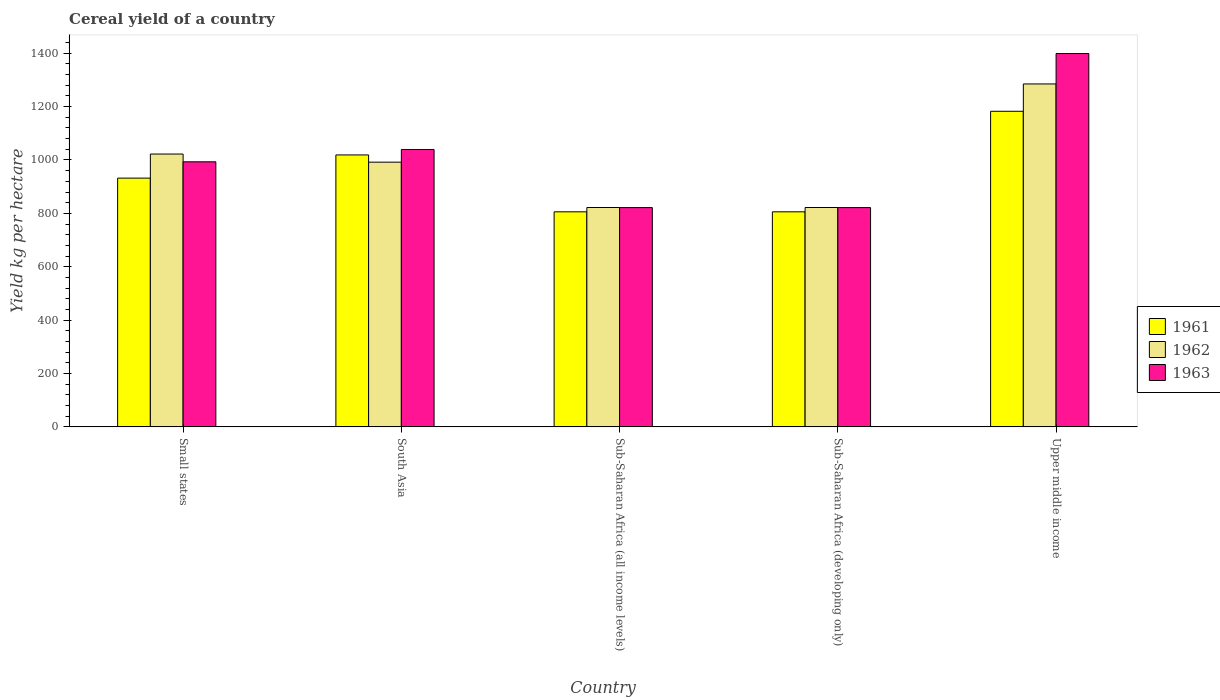Are the number of bars per tick equal to the number of legend labels?
Offer a very short reply. Yes. Are the number of bars on each tick of the X-axis equal?
Your answer should be very brief. Yes. How many bars are there on the 2nd tick from the left?
Keep it short and to the point. 3. What is the label of the 4th group of bars from the left?
Offer a terse response. Sub-Saharan Africa (developing only). What is the total cereal yield in 1963 in Sub-Saharan Africa (all income levels)?
Give a very brief answer. 821.71. Across all countries, what is the maximum total cereal yield in 1963?
Your answer should be very brief. 1398.9. Across all countries, what is the minimum total cereal yield in 1963?
Your response must be concise. 821.71. In which country was the total cereal yield in 1963 maximum?
Make the answer very short. Upper middle income. In which country was the total cereal yield in 1963 minimum?
Keep it short and to the point. Sub-Saharan Africa (all income levels). What is the total total cereal yield in 1961 in the graph?
Ensure brevity in your answer.  4745.3. What is the difference between the total cereal yield in 1962 in Sub-Saharan Africa (all income levels) and that in Sub-Saharan Africa (developing only)?
Keep it short and to the point. 0. What is the difference between the total cereal yield in 1963 in Small states and the total cereal yield in 1962 in South Asia?
Your answer should be very brief. 1.35. What is the average total cereal yield in 1963 per country?
Offer a terse response. 1015. What is the difference between the total cereal yield of/in 1961 and total cereal yield of/in 1962 in South Asia?
Offer a very short reply. 27.06. What is the ratio of the total cereal yield in 1962 in South Asia to that in Upper middle income?
Offer a terse response. 0.77. Is the total cereal yield in 1961 in Small states less than that in Upper middle income?
Make the answer very short. Yes. Is the difference between the total cereal yield in 1961 in Small states and South Asia greater than the difference between the total cereal yield in 1962 in Small states and South Asia?
Offer a very short reply. No. What is the difference between the highest and the second highest total cereal yield in 1962?
Your response must be concise. 262.66. What is the difference between the highest and the lowest total cereal yield in 1962?
Offer a terse response. 463. In how many countries, is the total cereal yield in 1962 greater than the average total cereal yield in 1962 taken over all countries?
Your response must be concise. 3. Is the sum of the total cereal yield in 1963 in Sub-Saharan Africa (all income levels) and Sub-Saharan Africa (developing only) greater than the maximum total cereal yield in 1961 across all countries?
Provide a short and direct response. Yes. What does the 1st bar from the left in Sub-Saharan Africa (developing only) represents?
Make the answer very short. 1961. How many bars are there?
Offer a very short reply. 15. Are all the bars in the graph horizontal?
Give a very brief answer. No. Are the values on the major ticks of Y-axis written in scientific E-notation?
Keep it short and to the point. No. Does the graph contain grids?
Give a very brief answer. No. What is the title of the graph?
Provide a succinct answer. Cereal yield of a country. What is the label or title of the X-axis?
Keep it short and to the point. Country. What is the label or title of the Y-axis?
Your answer should be compact. Yield kg per hectare. What is the Yield kg per hectare in 1961 in Small states?
Offer a very short reply. 932.09. What is the Yield kg per hectare of 1962 in Small states?
Your answer should be very brief. 1022.32. What is the Yield kg per hectare of 1963 in Small states?
Offer a terse response. 993.25. What is the Yield kg per hectare of 1961 in South Asia?
Offer a terse response. 1018.97. What is the Yield kg per hectare in 1962 in South Asia?
Provide a succinct answer. 991.91. What is the Yield kg per hectare of 1963 in South Asia?
Your answer should be compact. 1039.43. What is the Yield kg per hectare of 1961 in Sub-Saharan Africa (all income levels)?
Offer a very short reply. 805.83. What is the Yield kg per hectare of 1962 in Sub-Saharan Africa (all income levels)?
Provide a succinct answer. 821.98. What is the Yield kg per hectare of 1963 in Sub-Saharan Africa (all income levels)?
Offer a very short reply. 821.71. What is the Yield kg per hectare in 1961 in Sub-Saharan Africa (developing only)?
Keep it short and to the point. 805.83. What is the Yield kg per hectare of 1962 in Sub-Saharan Africa (developing only)?
Offer a very short reply. 821.98. What is the Yield kg per hectare of 1963 in Sub-Saharan Africa (developing only)?
Your response must be concise. 821.71. What is the Yield kg per hectare of 1961 in Upper middle income?
Provide a succinct answer. 1182.58. What is the Yield kg per hectare in 1962 in Upper middle income?
Ensure brevity in your answer.  1284.98. What is the Yield kg per hectare of 1963 in Upper middle income?
Provide a succinct answer. 1398.9. Across all countries, what is the maximum Yield kg per hectare in 1961?
Your answer should be compact. 1182.58. Across all countries, what is the maximum Yield kg per hectare of 1962?
Offer a very short reply. 1284.98. Across all countries, what is the maximum Yield kg per hectare of 1963?
Ensure brevity in your answer.  1398.9. Across all countries, what is the minimum Yield kg per hectare in 1961?
Give a very brief answer. 805.83. Across all countries, what is the minimum Yield kg per hectare in 1962?
Your answer should be very brief. 821.98. Across all countries, what is the minimum Yield kg per hectare in 1963?
Provide a succinct answer. 821.71. What is the total Yield kg per hectare of 1961 in the graph?
Provide a succinct answer. 4745.3. What is the total Yield kg per hectare in 1962 in the graph?
Provide a short and direct response. 4943.16. What is the total Yield kg per hectare in 1963 in the graph?
Keep it short and to the point. 5075. What is the difference between the Yield kg per hectare of 1961 in Small states and that in South Asia?
Make the answer very short. -86.87. What is the difference between the Yield kg per hectare of 1962 in Small states and that in South Asia?
Your answer should be compact. 30.41. What is the difference between the Yield kg per hectare of 1963 in Small states and that in South Asia?
Provide a short and direct response. -46.18. What is the difference between the Yield kg per hectare of 1961 in Small states and that in Sub-Saharan Africa (all income levels)?
Your answer should be very brief. 126.26. What is the difference between the Yield kg per hectare in 1962 in Small states and that in Sub-Saharan Africa (all income levels)?
Offer a terse response. 200.34. What is the difference between the Yield kg per hectare in 1963 in Small states and that in Sub-Saharan Africa (all income levels)?
Offer a very short reply. 171.55. What is the difference between the Yield kg per hectare of 1961 in Small states and that in Sub-Saharan Africa (developing only)?
Your response must be concise. 126.26. What is the difference between the Yield kg per hectare in 1962 in Small states and that in Sub-Saharan Africa (developing only)?
Provide a succinct answer. 200.34. What is the difference between the Yield kg per hectare in 1963 in Small states and that in Sub-Saharan Africa (developing only)?
Your response must be concise. 171.55. What is the difference between the Yield kg per hectare of 1961 in Small states and that in Upper middle income?
Offer a very short reply. -250.48. What is the difference between the Yield kg per hectare of 1962 in Small states and that in Upper middle income?
Your answer should be very brief. -262.66. What is the difference between the Yield kg per hectare in 1963 in Small states and that in Upper middle income?
Your response must be concise. -405.65. What is the difference between the Yield kg per hectare in 1961 in South Asia and that in Sub-Saharan Africa (all income levels)?
Ensure brevity in your answer.  213.14. What is the difference between the Yield kg per hectare of 1962 in South Asia and that in Sub-Saharan Africa (all income levels)?
Your response must be concise. 169.93. What is the difference between the Yield kg per hectare in 1963 in South Asia and that in Sub-Saharan Africa (all income levels)?
Keep it short and to the point. 217.72. What is the difference between the Yield kg per hectare of 1961 in South Asia and that in Sub-Saharan Africa (developing only)?
Your answer should be very brief. 213.14. What is the difference between the Yield kg per hectare of 1962 in South Asia and that in Sub-Saharan Africa (developing only)?
Offer a very short reply. 169.93. What is the difference between the Yield kg per hectare in 1963 in South Asia and that in Sub-Saharan Africa (developing only)?
Give a very brief answer. 217.72. What is the difference between the Yield kg per hectare in 1961 in South Asia and that in Upper middle income?
Your response must be concise. -163.61. What is the difference between the Yield kg per hectare in 1962 in South Asia and that in Upper middle income?
Offer a very short reply. -293.07. What is the difference between the Yield kg per hectare of 1963 in South Asia and that in Upper middle income?
Make the answer very short. -359.47. What is the difference between the Yield kg per hectare of 1961 in Sub-Saharan Africa (all income levels) and that in Sub-Saharan Africa (developing only)?
Make the answer very short. 0. What is the difference between the Yield kg per hectare of 1962 in Sub-Saharan Africa (all income levels) and that in Sub-Saharan Africa (developing only)?
Your answer should be very brief. 0. What is the difference between the Yield kg per hectare in 1963 in Sub-Saharan Africa (all income levels) and that in Sub-Saharan Africa (developing only)?
Offer a very short reply. 0. What is the difference between the Yield kg per hectare of 1961 in Sub-Saharan Africa (all income levels) and that in Upper middle income?
Give a very brief answer. -376.75. What is the difference between the Yield kg per hectare of 1962 in Sub-Saharan Africa (all income levels) and that in Upper middle income?
Your answer should be compact. -463. What is the difference between the Yield kg per hectare in 1963 in Sub-Saharan Africa (all income levels) and that in Upper middle income?
Offer a terse response. -577.19. What is the difference between the Yield kg per hectare in 1961 in Sub-Saharan Africa (developing only) and that in Upper middle income?
Your answer should be compact. -376.75. What is the difference between the Yield kg per hectare of 1962 in Sub-Saharan Africa (developing only) and that in Upper middle income?
Offer a very short reply. -463. What is the difference between the Yield kg per hectare in 1963 in Sub-Saharan Africa (developing only) and that in Upper middle income?
Your answer should be compact. -577.19. What is the difference between the Yield kg per hectare of 1961 in Small states and the Yield kg per hectare of 1962 in South Asia?
Offer a terse response. -59.81. What is the difference between the Yield kg per hectare in 1961 in Small states and the Yield kg per hectare in 1963 in South Asia?
Your answer should be compact. -107.33. What is the difference between the Yield kg per hectare in 1962 in Small states and the Yield kg per hectare in 1963 in South Asia?
Your answer should be compact. -17.11. What is the difference between the Yield kg per hectare of 1961 in Small states and the Yield kg per hectare of 1962 in Sub-Saharan Africa (all income levels)?
Your answer should be compact. 110.12. What is the difference between the Yield kg per hectare of 1961 in Small states and the Yield kg per hectare of 1963 in Sub-Saharan Africa (all income levels)?
Your response must be concise. 110.39. What is the difference between the Yield kg per hectare of 1962 in Small states and the Yield kg per hectare of 1963 in Sub-Saharan Africa (all income levels)?
Give a very brief answer. 200.61. What is the difference between the Yield kg per hectare of 1961 in Small states and the Yield kg per hectare of 1962 in Sub-Saharan Africa (developing only)?
Provide a short and direct response. 110.12. What is the difference between the Yield kg per hectare of 1961 in Small states and the Yield kg per hectare of 1963 in Sub-Saharan Africa (developing only)?
Your answer should be compact. 110.39. What is the difference between the Yield kg per hectare of 1962 in Small states and the Yield kg per hectare of 1963 in Sub-Saharan Africa (developing only)?
Make the answer very short. 200.61. What is the difference between the Yield kg per hectare of 1961 in Small states and the Yield kg per hectare of 1962 in Upper middle income?
Provide a short and direct response. -352.88. What is the difference between the Yield kg per hectare in 1961 in Small states and the Yield kg per hectare in 1963 in Upper middle income?
Your answer should be compact. -466.81. What is the difference between the Yield kg per hectare of 1962 in Small states and the Yield kg per hectare of 1963 in Upper middle income?
Your answer should be compact. -376.58. What is the difference between the Yield kg per hectare in 1961 in South Asia and the Yield kg per hectare in 1962 in Sub-Saharan Africa (all income levels)?
Provide a succinct answer. 196.99. What is the difference between the Yield kg per hectare in 1961 in South Asia and the Yield kg per hectare in 1963 in Sub-Saharan Africa (all income levels)?
Provide a succinct answer. 197.26. What is the difference between the Yield kg per hectare in 1962 in South Asia and the Yield kg per hectare in 1963 in Sub-Saharan Africa (all income levels)?
Keep it short and to the point. 170.2. What is the difference between the Yield kg per hectare in 1961 in South Asia and the Yield kg per hectare in 1962 in Sub-Saharan Africa (developing only)?
Your response must be concise. 196.99. What is the difference between the Yield kg per hectare in 1961 in South Asia and the Yield kg per hectare in 1963 in Sub-Saharan Africa (developing only)?
Provide a short and direct response. 197.26. What is the difference between the Yield kg per hectare of 1962 in South Asia and the Yield kg per hectare of 1963 in Sub-Saharan Africa (developing only)?
Offer a terse response. 170.2. What is the difference between the Yield kg per hectare of 1961 in South Asia and the Yield kg per hectare of 1962 in Upper middle income?
Ensure brevity in your answer.  -266.01. What is the difference between the Yield kg per hectare in 1961 in South Asia and the Yield kg per hectare in 1963 in Upper middle income?
Your response must be concise. -379.94. What is the difference between the Yield kg per hectare of 1962 in South Asia and the Yield kg per hectare of 1963 in Upper middle income?
Your response must be concise. -407. What is the difference between the Yield kg per hectare of 1961 in Sub-Saharan Africa (all income levels) and the Yield kg per hectare of 1962 in Sub-Saharan Africa (developing only)?
Your response must be concise. -16.15. What is the difference between the Yield kg per hectare of 1961 in Sub-Saharan Africa (all income levels) and the Yield kg per hectare of 1963 in Sub-Saharan Africa (developing only)?
Offer a very short reply. -15.88. What is the difference between the Yield kg per hectare in 1962 in Sub-Saharan Africa (all income levels) and the Yield kg per hectare in 1963 in Sub-Saharan Africa (developing only)?
Your answer should be very brief. 0.27. What is the difference between the Yield kg per hectare in 1961 in Sub-Saharan Africa (all income levels) and the Yield kg per hectare in 1962 in Upper middle income?
Offer a very short reply. -479.15. What is the difference between the Yield kg per hectare of 1961 in Sub-Saharan Africa (all income levels) and the Yield kg per hectare of 1963 in Upper middle income?
Your response must be concise. -593.07. What is the difference between the Yield kg per hectare in 1962 in Sub-Saharan Africa (all income levels) and the Yield kg per hectare in 1963 in Upper middle income?
Your response must be concise. -576.92. What is the difference between the Yield kg per hectare of 1961 in Sub-Saharan Africa (developing only) and the Yield kg per hectare of 1962 in Upper middle income?
Provide a succinct answer. -479.15. What is the difference between the Yield kg per hectare of 1961 in Sub-Saharan Africa (developing only) and the Yield kg per hectare of 1963 in Upper middle income?
Your answer should be compact. -593.07. What is the difference between the Yield kg per hectare in 1962 in Sub-Saharan Africa (developing only) and the Yield kg per hectare in 1963 in Upper middle income?
Your answer should be compact. -576.92. What is the average Yield kg per hectare in 1961 per country?
Keep it short and to the point. 949.06. What is the average Yield kg per hectare in 1962 per country?
Your response must be concise. 988.63. What is the average Yield kg per hectare in 1963 per country?
Provide a short and direct response. 1015. What is the difference between the Yield kg per hectare in 1961 and Yield kg per hectare in 1962 in Small states?
Provide a succinct answer. -90.22. What is the difference between the Yield kg per hectare of 1961 and Yield kg per hectare of 1963 in Small states?
Provide a short and direct response. -61.16. What is the difference between the Yield kg per hectare of 1962 and Yield kg per hectare of 1963 in Small states?
Your response must be concise. 29.06. What is the difference between the Yield kg per hectare of 1961 and Yield kg per hectare of 1962 in South Asia?
Your answer should be compact. 27.06. What is the difference between the Yield kg per hectare in 1961 and Yield kg per hectare in 1963 in South Asia?
Make the answer very short. -20.46. What is the difference between the Yield kg per hectare in 1962 and Yield kg per hectare in 1963 in South Asia?
Give a very brief answer. -47.52. What is the difference between the Yield kg per hectare of 1961 and Yield kg per hectare of 1962 in Sub-Saharan Africa (all income levels)?
Your response must be concise. -16.15. What is the difference between the Yield kg per hectare in 1961 and Yield kg per hectare in 1963 in Sub-Saharan Africa (all income levels)?
Your response must be concise. -15.88. What is the difference between the Yield kg per hectare of 1962 and Yield kg per hectare of 1963 in Sub-Saharan Africa (all income levels)?
Offer a terse response. 0.27. What is the difference between the Yield kg per hectare of 1961 and Yield kg per hectare of 1962 in Sub-Saharan Africa (developing only)?
Offer a very short reply. -16.15. What is the difference between the Yield kg per hectare of 1961 and Yield kg per hectare of 1963 in Sub-Saharan Africa (developing only)?
Give a very brief answer. -15.88. What is the difference between the Yield kg per hectare of 1962 and Yield kg per hectare of 1963 in Sub-Saharan Africa (developing only)?
Provide a short and direct response. 0.27. What is the difference between the Yield kg per hectare in 1961 and Yield kg per hectare in 1962 in Upper middle income?
Provide a succinct answer. -102.4. What is the difference between the Yield kg per hectare in 1961 and Yield kg per hectare in 1963 in Upper middle income?
Keep it short and to the point. -216.32. What is the difference between the Yield kg per hectare in 1962 and Yield kg per hectare in 1963 in Upper middle income?
Provide a succinct answer. -113.93. What is the ratio of the Yield kg per hectare of 1961 in Small states to that in South Asia?
Provide a short and direct response. 0.91. What is the ratio of the Yield kg per hectare in 1962 in Small states to that in South Asia?
Keep it short and to the point. 1.03. What is the ratio of the Yield kg per hectare of 1963 in Small states to that in South Asia?
Provide a short and direct response. 0.96. What is the ratio of the Yield kg per hectare of 1961 in Small states to that in Sub-Saharan Africa (all income levels)?
Keep it short and to the point. 1.16. What is the ratio of the Yield kg per hectare in 1962 in Small states to that in Sub-Saharan Africa (all income levels)?
Offer a terse response. 1.24. What is the ratio of the Yield kg per hectare in 1963 in Small states to that in Sub-Saharan Africa (all income levels)?
Give a very brief answer. 1.21. What is the ratio of the Yield kg per hectare in 1961 in Small states to that in Sub-Saharan Africa (developing only)?
Make the answer very short. 1.16. What is the ratio of the Yield kg per hectare of 1962 in Small states to that in Sub-Saharan Africa (developing only)?
Your answer should be very brief. 1.24. What is the ratio of the Yield kg per hectare in 1963 in Small states to that in Sub-Saharan Africa (developing only)?
Keep it short and to the point. 1.21. What is the ratio of the Yield kg per hectare in 1961 in Small states to that in Upper middle income?
Offer a terse response. 0.79. What is the ratio of the Yield kg per hectare in 1962 in Small states to that in Upper middle income?
Provide a short and direct response. 0.8. What is the ratio of the Yield kg per hectare of 1963 in Small states to that in Upper middle income?
Your response must be concise. 0.71. What is the ratio of the Yield kg per hectare in 1961 in South Asia to that in Sub-Saharan Africa (all income levels)?
Your answer should be very brief. 1.26. What is the ratio of the Yield kg per hectare of 1962 in South Asia to that in Sub-Saharan Africa (all income levels)?
Ensure brevity in your answer.  1.21. What is the ratio of the Yield kg per hectare of 1963 in South Asia to that in Sub-Saharan Africa (all income levels)?
Provide a short and direct response. 1.26. What is the ratio of the Yield kg per hectare of 1961 in South Asia to that in Sub-Saharan Africa (developing only)?
Give a very brief answer. 1.26. What is the ratio of the Yield kg per hectare in 1962 in South Asia to that in Sub-Saharan Africa (developing only)?
Give a very brief answer. 1.21. What is the ratio of the Yield kg per hectare in 1963 in South Asia to that in Sub-Saharan Africa (developing only)?
Your answer should be very brief. 1.26. What is the ratio of the Yield kg per hectare of 1961 in South Asia to that in Upper middle income?
Provide a short and direct response. 0.86. What is the ratio of the Yield kg per hectare in 1962 in South Asia to that in Upper middle income?
Ensure brevity in your answer.  0.77. What is the ratio of the Yield kg per hectare of 1963 in South Asia to that in Upper middle income?
Your response must be concise. 0.74. What is the ratio of the Yield kg per hectare of 1962 in Sub-Saharan Africa (all income levels) to that in Sub-Saharan Africa (developing only)?
Provide a short and direct response. 1. What is the ratio of the Yield kg per hectare of 1961 in Sub-Saharan Africa (all income levels) to that in Upper middle income?
Keep it short and to the point. 0.68. What is the ratio of the Yield kg per hectare of 1962 in Sub-Saharan Africa (all income levels) to that in Upper middle income?
Keep it short and to the point. 0.64. What is the ratio of the Yield kg per hectare in 1963 in Sub-Saharan Africa (all income levels) to that in Upper middle income?
Offer a terse response. 0.59. What is the ratio of the Yield kg per hectare in 1961 in Sub-Saharan Africa (developing only) to that in Upper middle income?
Your response must be concise. 0.68. What is the ratio of the Yield kg per hectare in 1962 in Sub-Saharan Africa (developing only) to that in Upper middle income?
Provide a short and direct response. 0.64. What is the ratio of the Yield kg per hectare of 1963 in Sub-Saharan Africa (developing only) to that in Upper middle income?
Offer a very short reply. 0.59. What is the difference between the highest and the second highest Yield kg per hectare in 1961?
Provide a succinct answer. 163.61. What is the difference between the highest and the second highest Yield kg per hectare of 1962?
Offer a terse response. 262.66. What is the difference between the highest and the second highest Yield kg per hectare of 1963?
Your response must be concise. 359.47. What is the difference between the highest and the lowest Yield kg per hectare in 1961?
Your response must be concise. 376.75. What is the difference between the highest and the lowest Yield kg per hectare of 1962?
Your response must be concise. 463. What is the difference between the highest and the lowest Yield kg per hectare of 1963?
Keep it short and to the point. 577.19. 